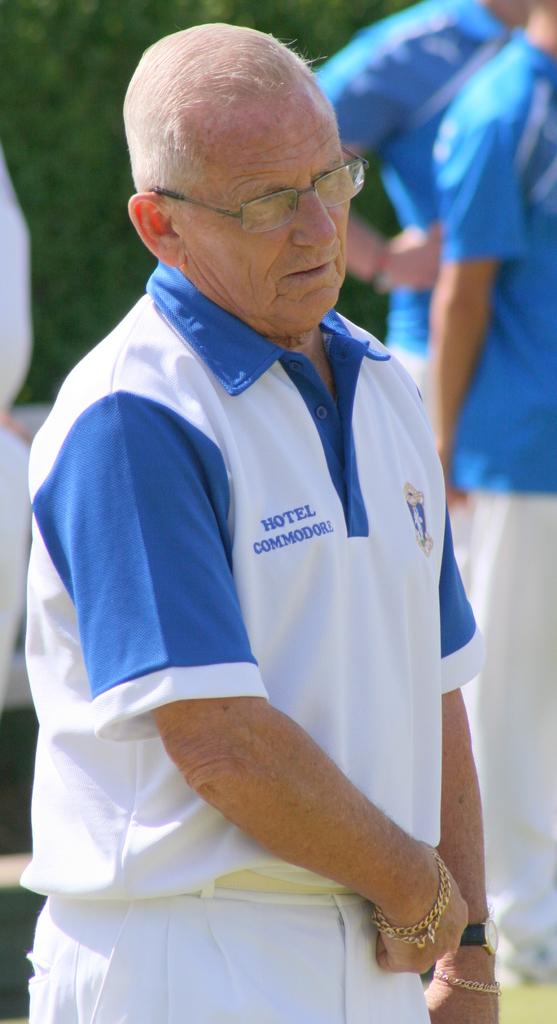What hotel is his shirt advertising?
Offer a very short reply. Commodore. 